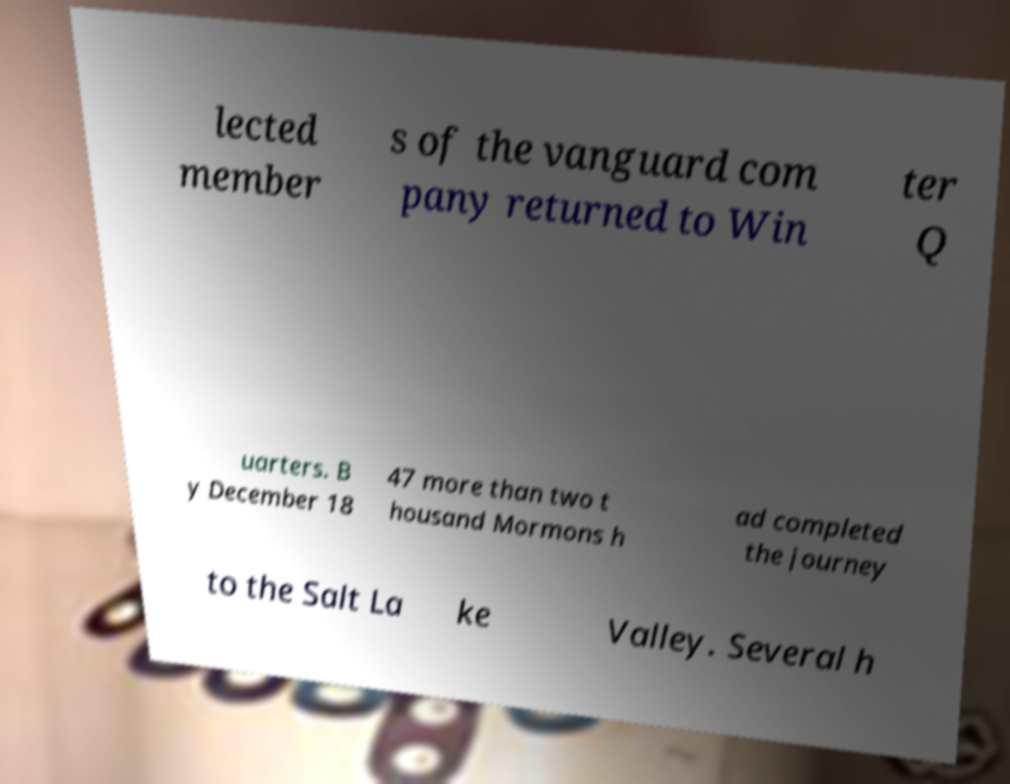I need the written content from this picture converted into text. Can you do that? lected member s of the vanguard com pany returned to Win ter Q uarters. B y December 18 47 more than two t housand Mormons h ad completed the journey to the Salt La ke Valley. Several h 